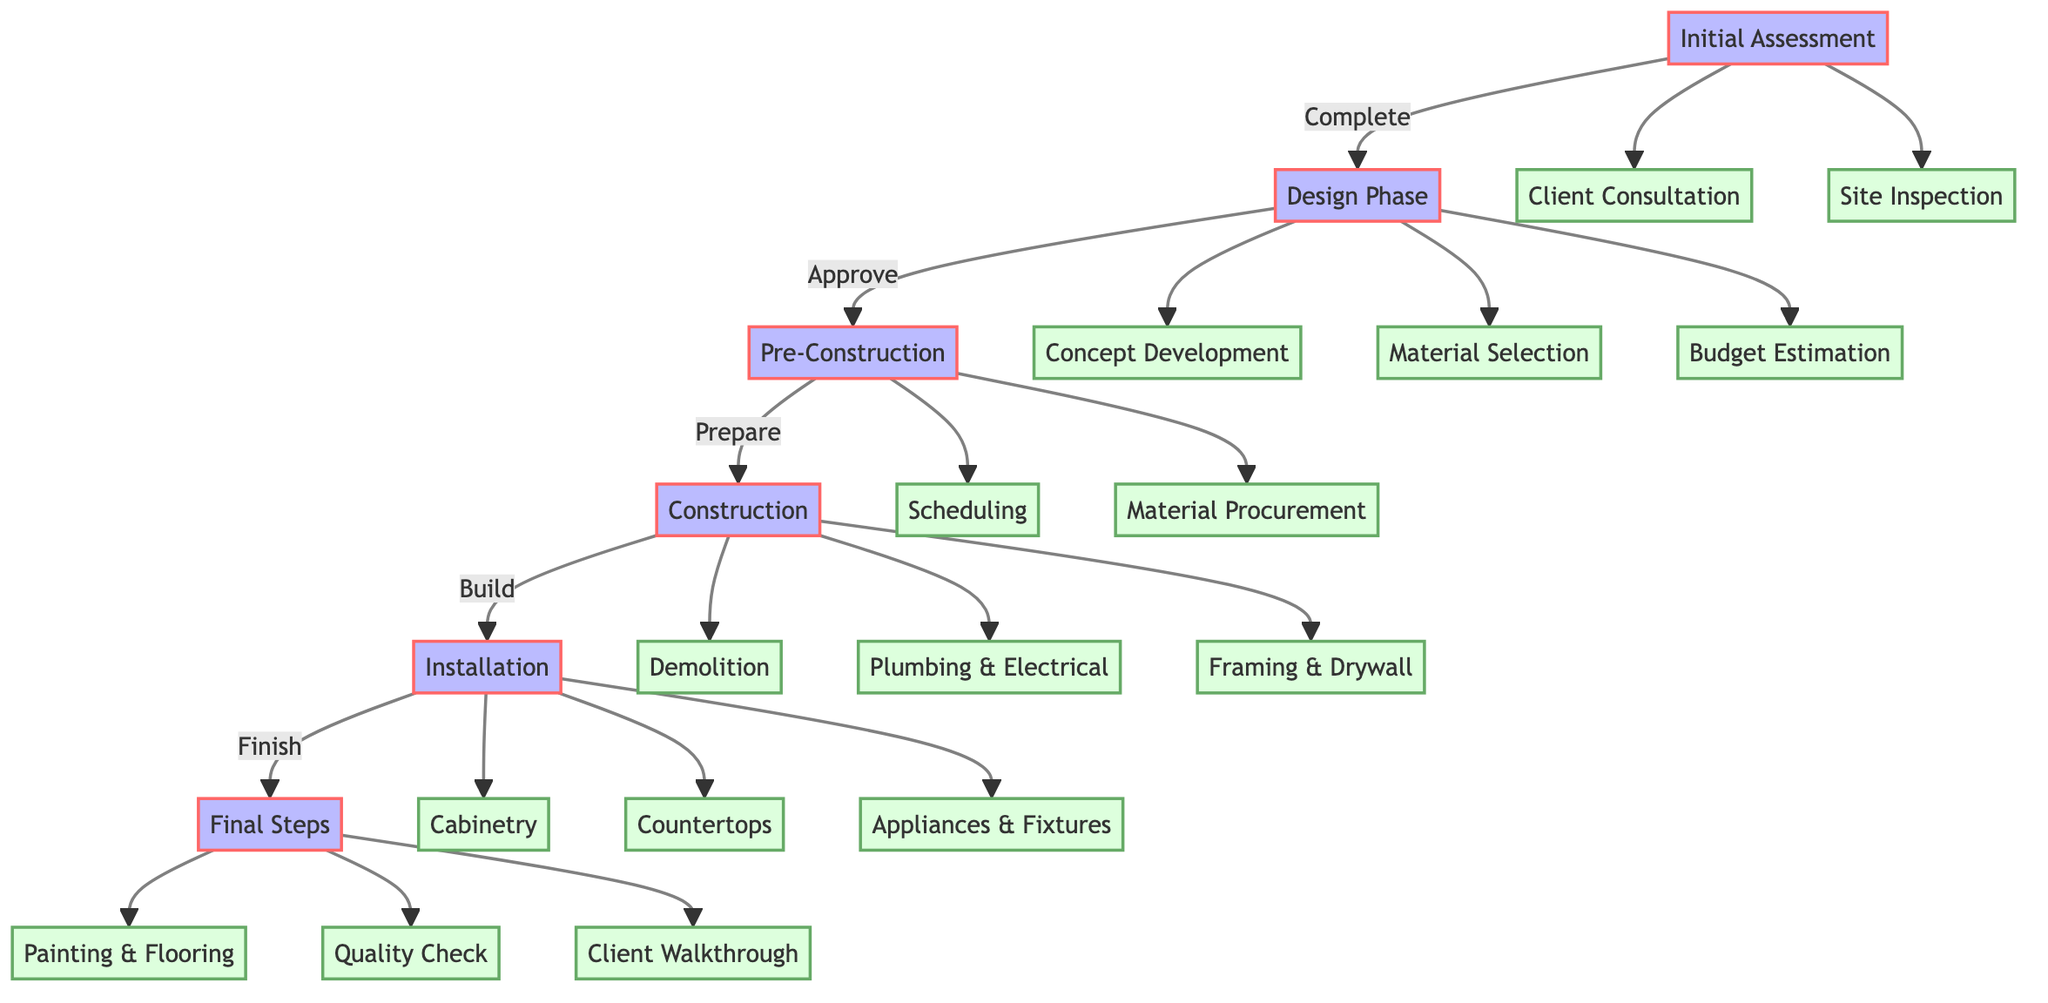What is the first step in the workflow? The first step in the workflow is "Initial Assessment," which includes meeting with the client and inspecting the site. This is indicated at the top of the diagram.
Answer: Initial Assessment How many phases are there in the workflow? The diagram lists a total of six distinct phases (Initial Assessment, Design Phase, Approval Phase, Pre-Construction Phase, Construction Phase, Installation Phase, Finishing Phase).
Answer: Six What happens if the client does not approve the design? If the client does not approve the design in the Approval Phase, the process cannot proceed to the subsequent phases, as indicated by the lack of a direct link to the next phase.
Answer: No progress Which phase comes after "Construction Phase"? The next phase after "Construction Phase" is "Installation Phase," showing the chronological flow of completing the renovation.
Answer: Installation Phase What task is associated with the "Final Steps" phase? The "Final Steps" phase includes "Quality Check," "Client Walkthrough," and "Project Completion," which encapsulates finalizing the project before handover to the client.
Answer: Quality Check What must be completed before material procurement can begin? Before "Material Procurement" can be initiated, the "Scheduling" task must be completed, indicating that a timeline for the project needs to be established first.
Answer: Scheduling Which task includes obtaining necessary permits? The task that includes obtaining necessary permits is "Permit Acquisition," which is part of the Approval Phase.
Answer: Permit Acquisition In which phase is the demolition of the old kitchen done? Demolition of the old kitchen occurs in the "Construction Phase," as explicitly shown in the diagram.
Answer: Construction Phase What are the last three tasks in the workflow? The last three tasks in the workflow are "Painting and Flooring," "Quality Check," and "Client Walkthrough," representing the concluding actions before project completion.
Answer: Painting and Flooring, Quality Check, Client Walkthrough 